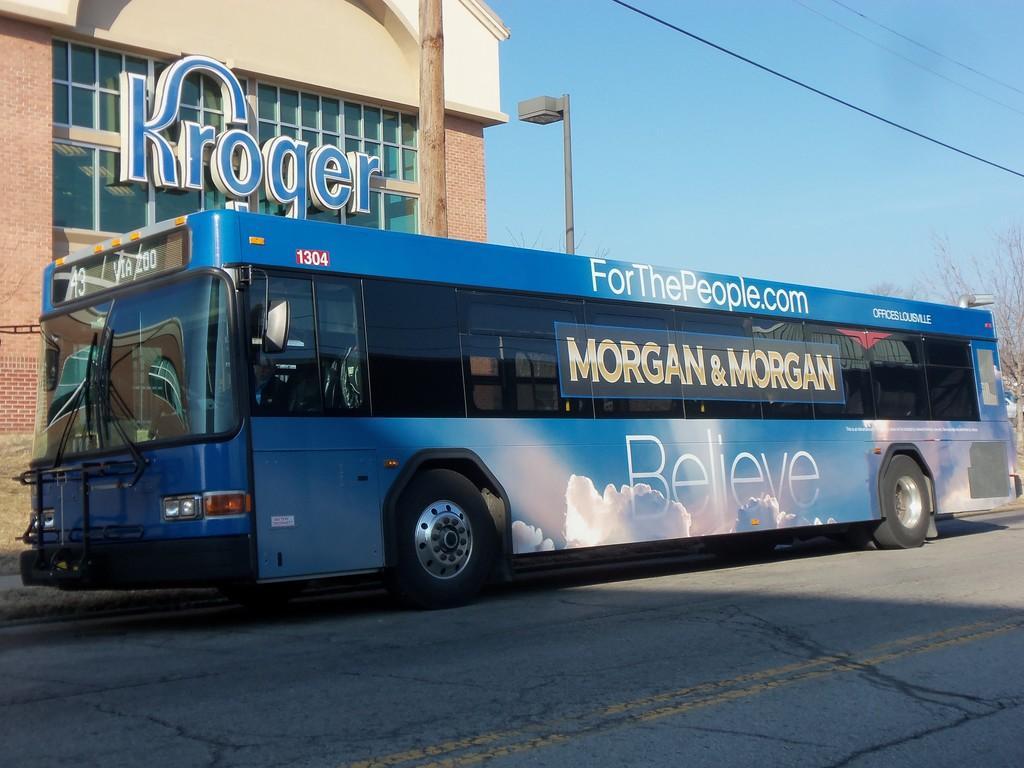Could you give a brief overview of what you see in this image? In this image I see a bus over here which is of blue in color and I see something is written on it and I see the road. In the background I see the building on which there is something written too and I see a pole over here and I see the wires and the trees and I see the sky. 